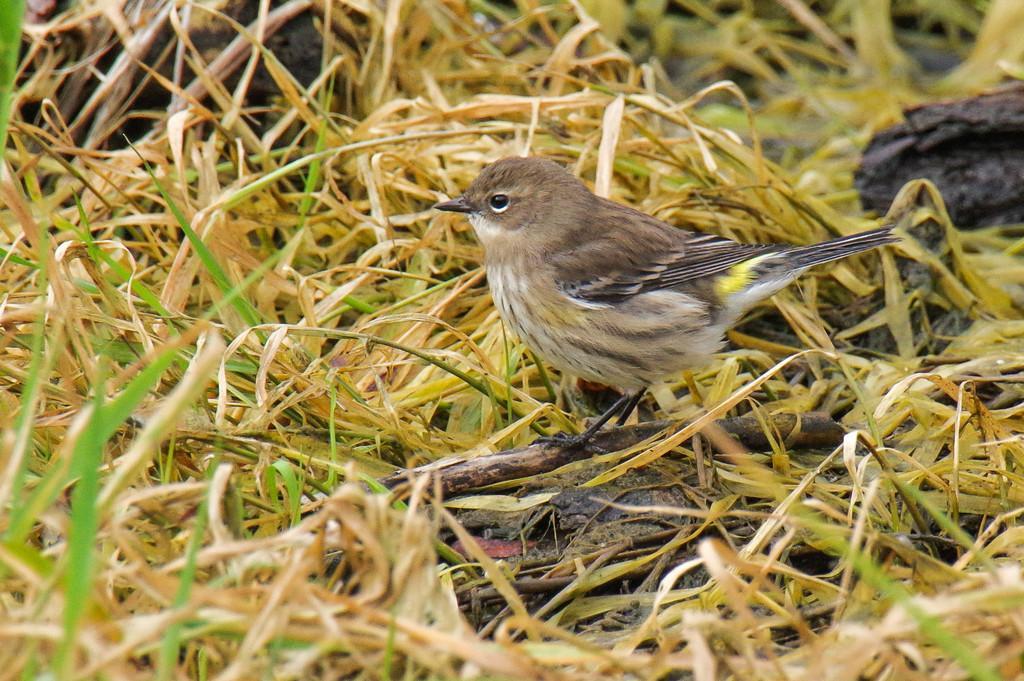Please provide a concise description of this image. In this image there is a bird standing on a stem. There is grass. There is mud. 